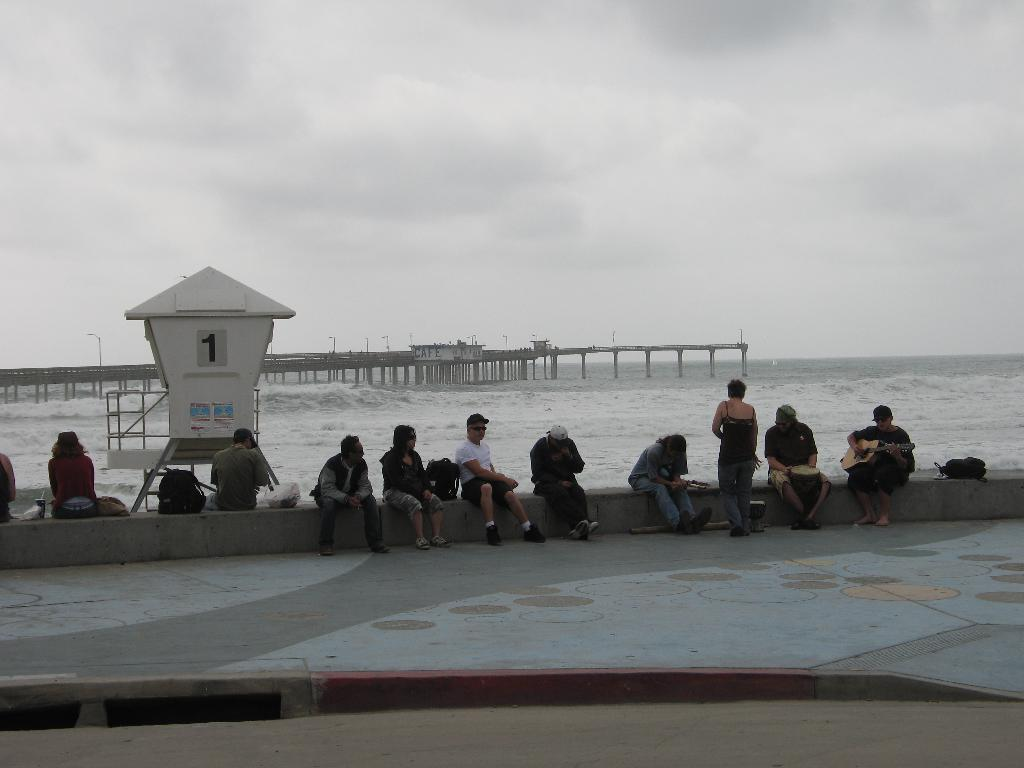What is the main activity of the people in the foreground of the image? The people are sitting near the sea in the foreground of the image. What natural feature is visible in the background of the image? The sea is visible in the background of the image. What man-made structure can be seen in the background of the image? There is a dock in the background of the image. What else can be seen in the background of the image? Poles and clouds are visible in the background of the image. What type of leaf is being used as a hat by the beast in the image? There is no beast or leaf present in the image. What kind of rod is being used by the people sitting near the sea? There is no rod visible in the image; the people are simply sitting near the sea. 